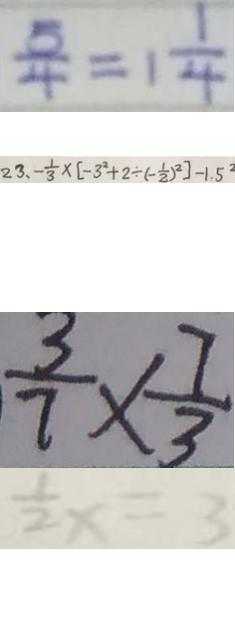Convert formula to latex. <formula><loc_0><loc_0><loc_500><loc_500>\frac { 5 } { 4 } = 1 \frac { 1 } { 4 } 
 2 3 、 - \frac { 1 } { 3 } \times [ - 3 ^ { 2 } + 2 \div ( - \frac { 1 } { 2 } ) ^ { 2 } ] - 1 . 5 ^ { 2 } 
 \frac { 3 } { 7 } \times \frac { 7 } { 3 } 
 \frac { 1 } { 2 } x = 3</formula> 